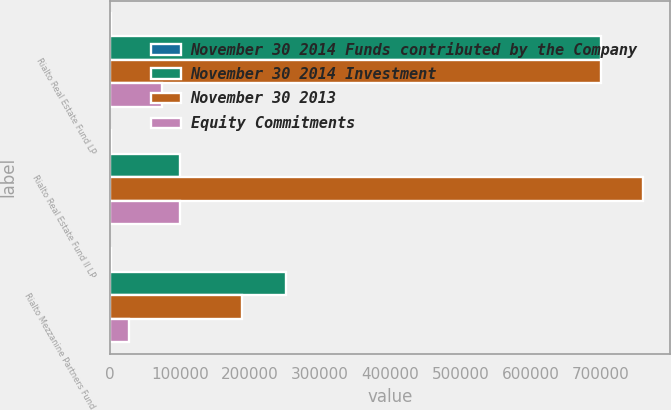Convert chart. <chart><loc_0><loc_0><loc_500><loc_500><stacked_bar_chart><ecel><fcel>Rialto Real Estate Fund LP<fcel>Rialto Real Estate Fund II LP<fcel>Rialto Mezzanine Partners Fund<nl><fcel>November 30 2014 Funds contributed by the Company<fcel>2010<fcel>2012<fcel>2013<nl><fcel>November 30 2014 Investment<fcel>700006<fcel>100000<fcel>251100<nl><fcel>November 30 2013<fcel>700006<fcel>760058<fcel>188600<nl><fcel>Equity Commitments<fcel>75000<fcel>100000<fcel>27299<nl></chart> 